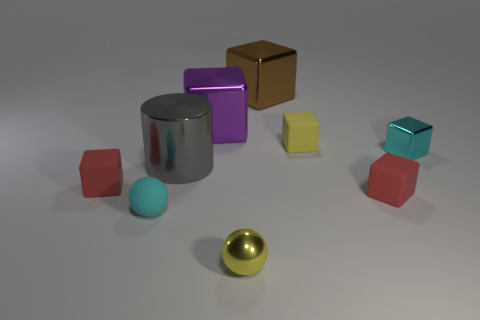Subtract all brown blocks. How many blocks are left? 5 Subtract all cylinders. How many objects are left? 8 Subtract 3 cubes. How many cubes are left? 3 Add 1 matte blocks. How many objects exist? 10 Subtract all yellow blocks. How many blocks are left? 5 Subtract 1 yellow cubes. How many objects are left? 8 Subtract all red cylinders. Subtract all brown blocks. How many cylinders are left? 1 Subtract all gray balls. How many yellow cubes are left? 1 Subtract all big gray cylinders. Subtract all large shiny things. How many objects are left? 5 Add 9 tiny yellow cubes. How many tiny yellow cubes are left? 10 